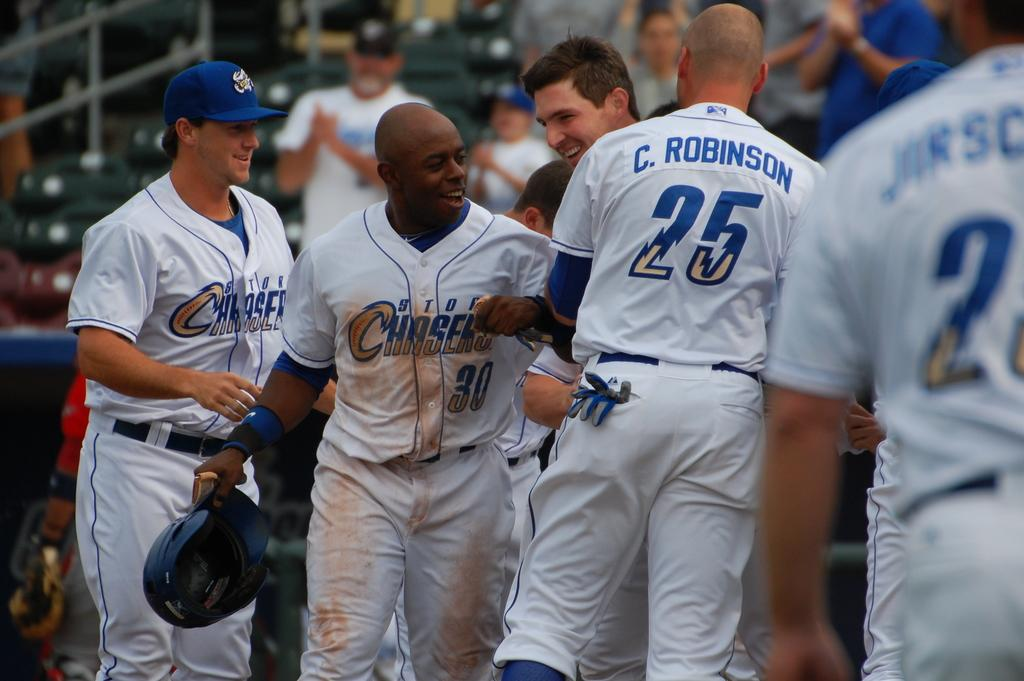Provide a one-sentence caption for the provided image. some players with one that wears the number 25. 